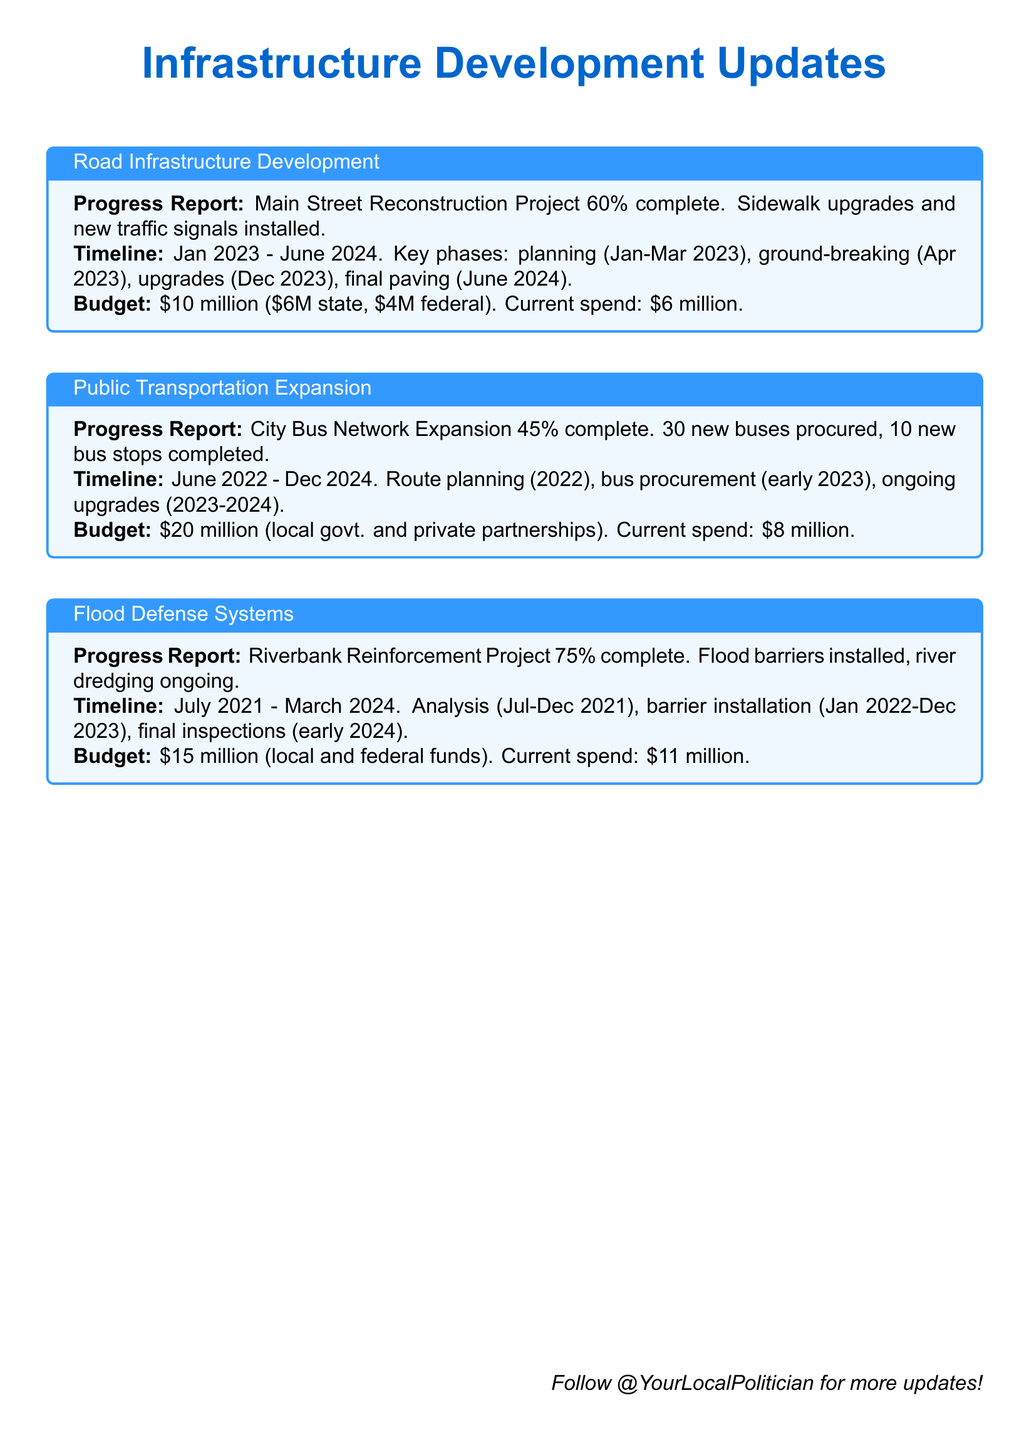What is the completion percentage of the Main Street Reconstruction Project? The document states that the Main Street Reconstruction Project is 60% complete.
Answer: 60% What is the total budget for the City Bus Network Expansion? The total budget for the City Bus Network Expansion is $20 million.
Answer: $20 million When is the final paving scheduled for the Main Street Reconstruction Project? According to the timeline provided, the final paving is scheduled for June 2024.
Answer: June 2024 What percentage is the Riverbank Reinforcement Project complete? The Riverbank Reinforcement Project is 75% complete.
Answer: 75% How much has been spent on the Flood Defense Systems project to date? The current spend on the Flood Defense Systems project is $11 million.
Answer: $11 million What is the starting date of the City Bus Network Expansion project? The starting date of the City Bus Network Expansion project is June 2022.
Answer: June 2022 How many new bus stops have been completed in the City Bus Network Expansion? The document reports that 10 new bus stops have been completed.
Answer: 10 What is the total budget of the Main Street Reconstruction Project? The total budget for the Main Street Reconstruction Project is $10 million.
Answer: $10 million Which project has the earliest start date? The City Bus Network Expansion project has the earliest start date in June 2022.
Answer: City Bus Network Expansion 